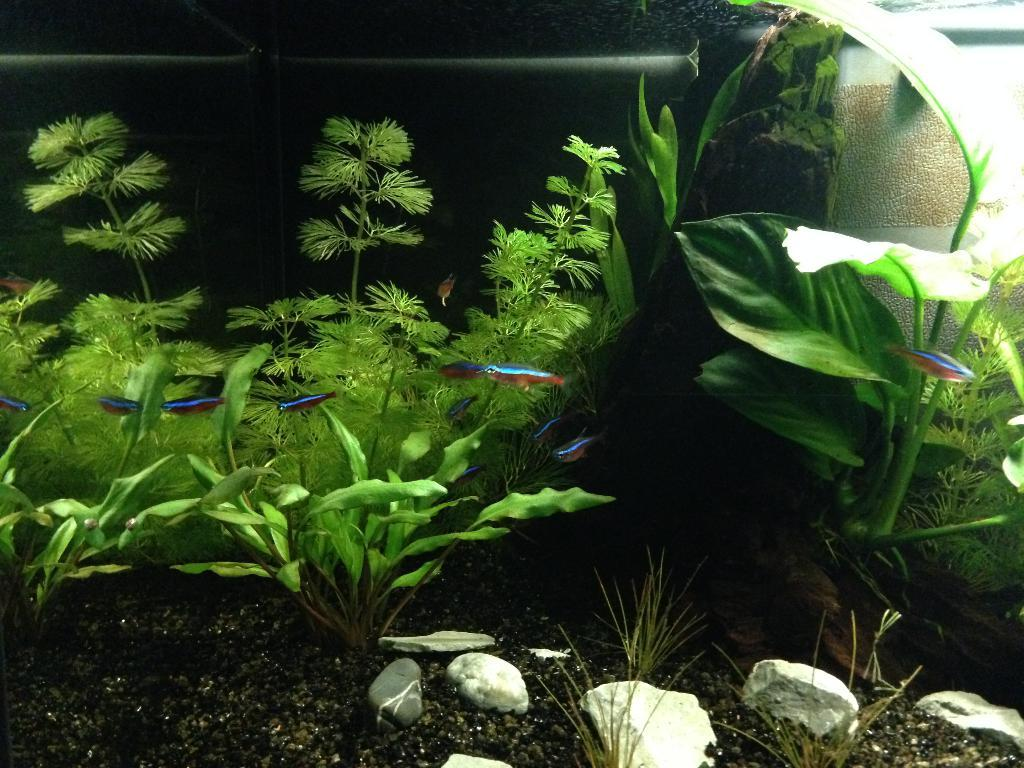What type of material is present in the image? There is soil and a stone in the image. What living organisms can be seen in the image? There are fishes in the image. What type of vegetation is present in the image? There are plants in the image. What object is used for fishing in the image? There is a rod in the image. What can be inferred about the setting of the image? The image appears to depict an aquarium. Who is the owner of the comb in the image? There is no comb present in the image. What type of drawer can be seen in the image? There is no drawer present in the image. 